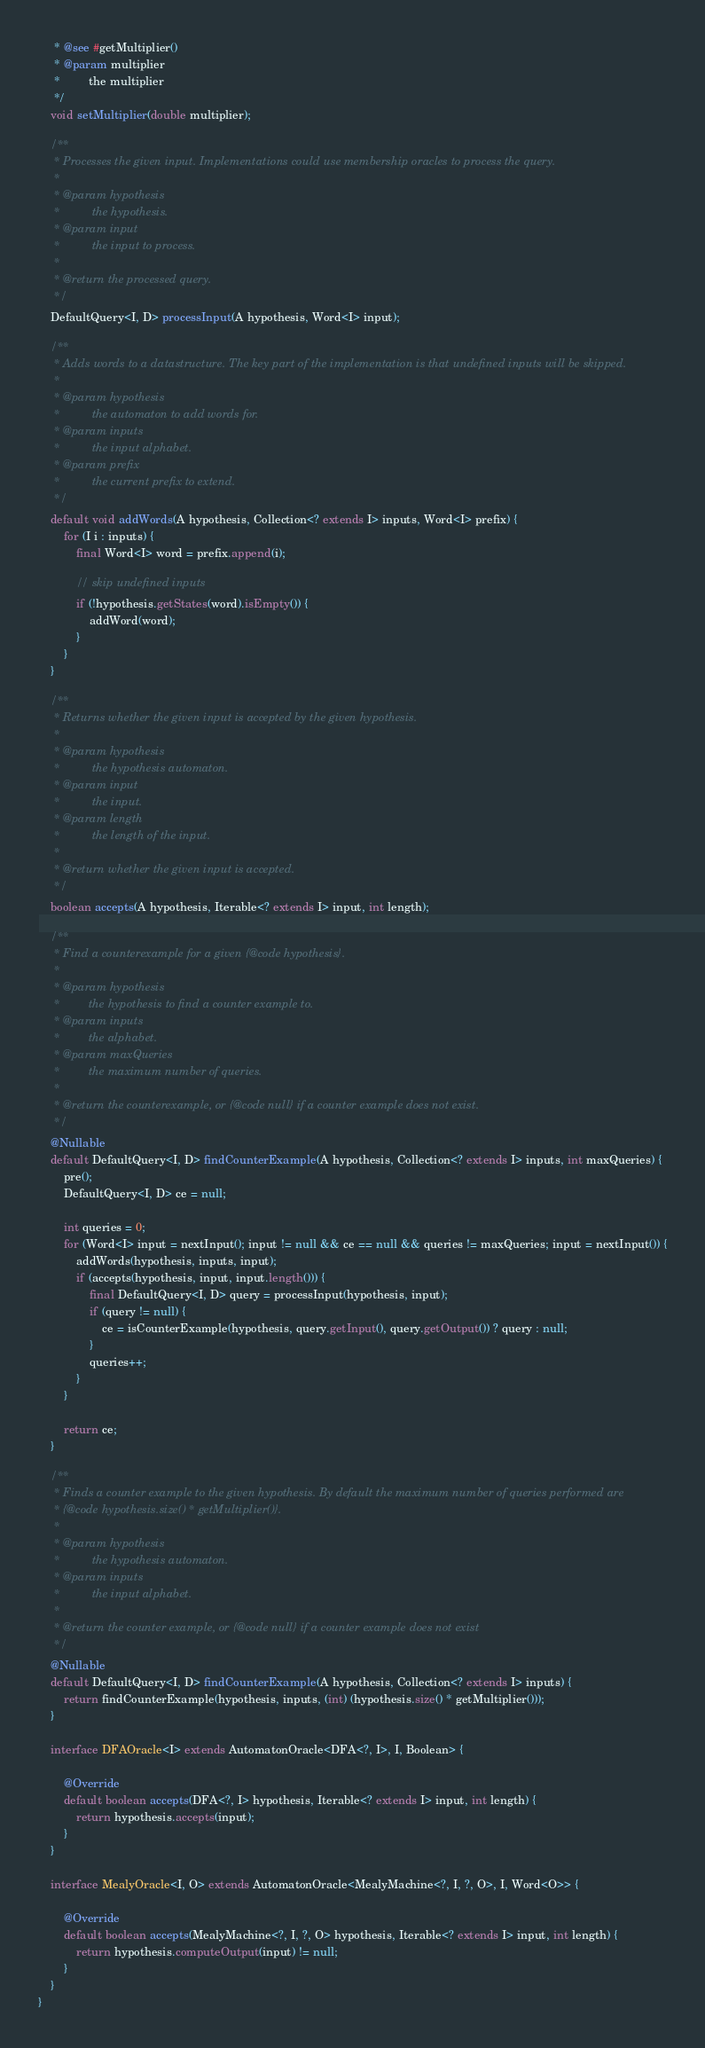Convert code to text. <code><loc_0><loc_0><loc_500><loc_500><_Java_>     * @see #getMultiplier()
     * @param multiplier
     *         the multiplier
     */
    void setMultiplier(double multiplier);

    /**
     * Processes the given input. Implementations could use membership oracles to process the query.
     *
     * @param hypothesis
     *          the hypothesis.
     * @param input
     *          the input to process.
     *
     * @return the processed query.
     */
    DefaultQuery<I, D> processInput(A hypothesis, Word<I> input);

    /**
     * Adds words to a datastructure. The key part of the implementation is that undefined inputs will be skipped.
     *
     * @param hypothesis
     *          the automaton to add words for.
     * @param inputs
     *          the input alphabet.
     * @param prefix
     *          the current prefix to extend.
     */
    default void addWords(A hypothesis, Collection<? extends I> inputs, Word<I> prefix) {
        for (I i : inputs) {
            final Word<I> word = prefix.append(i);

            // skip undefined inputs
            if (!hypothesis.getStates(word).isEmpty()) {
                addWord(word);
            }
        }
    }

    /**
     * Returns whether the given input is accepted by the given hypothesis.
     *
     * @param hypothesis
     *          the hypothesis automaton.
     * @param input
     *          the input.
     * @param length
     *          the length of the input.
     *
     * @return whether the given input is accepted.
     */
    boolean accepts(A hypothesis, Iterable<? extends I> input, int length);

    /**
     * Find a counterexample for a given {@code hypothesis}.
     *
     * @param hypothesis
     *         the hypothesis to find a counter example to.
     * @param inputs
     *         the alphabet.
     * @param maxQueries
     *         the maximum number of queries.
     *
     * @return the counterexample, or {@code null} if a counter example does not exist.
     */
    @Nullable
    default DefaultQuery<I, D> findCounterExample(A hypothesis, Collection<? extends I> inputs, int maxQueries) {
        pre();
        DefaultQuery<I, D> ce = null;

        int queries = 0;
        for (Word<I> input = nextInput(); input != null && ce == null && queries != maxQueries; input = nextInput()) {
            addWords(hypothesis, inputs, input);
            if (accepts(hypothesis, input, input.length())) {
                final DefaultQuery<I, D> query = processInput(hypothesis, input);
                if (query != null) {
                    ce = isCounterExample(hypothesis, query.getInput(), query.getOutput()) ? query : null;
                }
                queries++;
            }
        }

        return ce;
    }

    /**
     * Finds a counter example to the given hypothesis. By default the maximum number of queries performed are
     * {@code hypothesis.size() * getMultiplier()}.
     *
     * @param hypothesis
     *          the hypothesis automaton.
     * @param inputs
     *          the input alphabet.
     *
     * @return the counter example, or {@code null} if a counter example does not exist
     */
    @Nullable
    default DefaultQuery<I, D> findCounterExample(A hypothesis, Collection<? extends I> inputs) {
        return findCounterExample(hypothesis, inputs, (int) (hypothesis.size() * getMultiplier()));
    }

    interface DFAOracle<I> extends AutomatonOracle<DFA<?, I>, I, Boolean> {

        @Override
        default boolean accepts(DFA<?, I> hypothesis, Iterable<? extends I> input, int length) {
            return hypothesis.accepts(input);
        }
    }

    interface MealyOracle<I, O> extends AutomatonOracle<MealyMachine<?, I, ?, O>, I, Word<O>> {

        @Override
        default boolean accepts(MealyMachine<?, I, ?, O> hypothesis, Iterable<? extends I> input, int length) {
            return hypothesis.computeOutput(input) != null;
        }
    }
}
</code> 